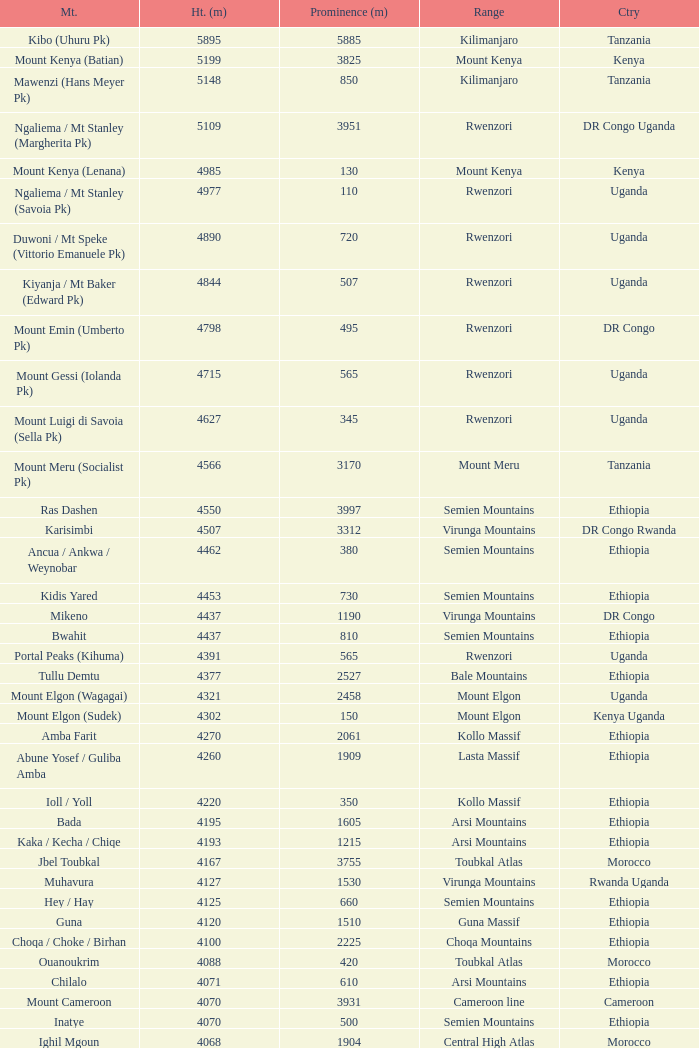Which Country has a Height (m) larger than 4100, and a Range of arsi mountains, and a Mountain of bada? Ethiopia. Can you give me this table as a dict? {'header': ['Mt.', 'Ht. (m)', 'Prominence (m)', 'Range', 'Ctry'], 'rows': [['Kibo (Uhuru Pk)', '5895', '5885', 'Kilimanjaro', 'Tanzania'], ['Mount Kenya (Batian)', '5199', '3825', 'Mount Kenya', 'Kenya'], ['Mawenzi (Hans Meyer Pk)', '5148', '850', 'Kilimanjaro', 'Tanzania'], ['Ngaliema / Mt Stanley (Margherita Pk)', '5109', '3951', 'Rwenzori', 'DR Congo Uganda'], ['Mount Kenya (Lenana)', '4985', '130', 'Mount Kenya', 'Kenya'], ['Ngaliema / Mt Stanley (Savoia Pk)', '4977', '110', 'Rwenzori', 'Uganda'], ['Duwoni / Mt Speke (Vittorio Emanuele Pk)', '4890', '720', 'Rwenzori', 'Uganda'], ['Kiyanja / Mt Baker (Edward Pk)', '4844', '507', 'Rwenzori', 'Uganda'], ['Mount Emin (Umberto Pk)', '4798', '495', 'Rwenzori', 'DR Congo'], ['Mount Gessi (Iolanda Pk)', '4715', '565', 'Rwenzori', 'Uganda'], ['Mount Luigi di Savoia (Sella Pk)', '4627', '345', 'Rwenzori', 'Uganda'], ['Mount Meru (Socialist Pk)', '4566', '3170', 'Mount Meru', 'Tanzania'], ['Ras Dashen', '4550', '3997', 'Semien Mountains', 'Ethiopia'], ['Karisimbi', '4507', '3312', 'Virunga Mountains', 'DR Congo Rwanda'], ['Ancua / Ankwa / Weynobar', '4462', '380', 'Semien Mountains', 'Ethiopia'], ['Kidis Yared', '4453', '730', 'Semien Mountains', 'Ethiopia'], ['Mikeno', '4437', '1190', 'Virunga Mountains', 'DR Congo'], ['Bwahit', '4437', '810', 'Semien Mountains', 'Ethiopia'], ['Portal Peaks (Kihuma)', '4391', '565', 'Rwenzori', 'Uganda'], ['Tullu Demtu', '4377', '2527', 'Bale Mountains', 'Ethiopia'], ['Mount Elgon (Wagagai)', '4321', '2458', 'Mount Elgon', 'Uganda'], ['Mount Elgon (Sudek)', '4302', '150', 'Mount Elgon', 'Kenya Uganda'], ['Amba Farit', '4270', '2061', 'Kollo Massif', 'Ethiopia'], ['Abune Yosef / Guliba Amba', '4260', '1909', 'Lasta Massif', 'Ethiopia'], ['Ioll / Yoll', '4220', '350', 'Kollo Massif', 'Ethiopia'], ['Bada', '4195', '1605', 'Arsi Mountains', 'Ethiopia'], ['Kaka / Kecha / Chiqe', '4193', '1215', 'Arsi Mountains', 'Ethiopia'], ['Jbel Toubkal', '4167', '3755', 'Toubkal Atlas', 'Morocco'], ['Muhavura', '4127', '1530', 'Virunga Mountains', 'Rwanda Uganda'], ['Hey / Hay', '4125', '660', 'Semien Mountains', 'Ethiopia'], ['Guna', '4120', '1510', 'Guna Massif', 'Ethiopia'], ['Choqa / Choke / Birhan', '4100', '2225', 'Choqa Mountains', 'Ethiopia'], ['Ouanoukrim', '4088', '420', 'Toubkal Atlas', 'Morocco'], ['Chilalo', '4071', '610', 'Arsi Mountains', 'Ethiopia'], ['Mount Cameroon', '4070', '3931', 'Cameroon line', 'Cameroon'], ['Inatye', '4070', '500', 'Semien Mountains', 'Ethiopia'], ['Ighil Mgoun', '4068', '1904', 'Central High Atlas', 'Morocco'], ['Weshema / Wasema?', '4030', '420', 'Bale Mountains', 'Ethiopia'], ['Oldoinyo Lesatima', '4001', '2081', 'Aberdare Range', 'Kenya'], ["Jebel n'Tarourt / Tifnout / Iferouane", '3996', '910', 'Toubkal Atlas', 'Morocco'], ['Muggia', '3950', '500', 'Lasta Massif', 'Ethiopia'], ['Dubbai', '3941', '1540', 'Tigray Mountains', 'Ethiopia'], ['Taska n’Zat', '3912', '460', 'Toubkal Atlas', 'Morocco'], ['Aksouâl', '3903', '450', 'Toubkal Atlas', 'Morocco'], ['Mount Kinangop', '3902', '530', 'Aberdare Range', 'Kenya'], ['Cimbia', '3900', '590', 'Kollo Massif', 'Ethiopia'], ['Anrhemer / Ingehmar', '3892', '380', 'Toubkal Atlas', 'Morocco'], ['Ieciuol ?', '3840', '560', 'Kollo Massif', 'Ethiopia'], ['Kawa / Caua / Lajo', '3830', '475', 'Bale Mountains', 'Ethiopia'], ['Pt 3820', '3820', '450', 'Kollo Massif', 'Ethiopia'], ['Jbel Tignousti', '3819', '930', 'Central High Atlas', 'Morocco'], ['Filfo / Encuolo', '3805', '770', 'Arsi Mountains', 'Ethiopia'], ['Kosso Amba', '3805', '530', 'Lasta Massif', 'Ethiopia'], ['Jbel Ghat', '3781', '470', 'Central High Atlas', 'Morocco'], ['Baylamtu / Gavsigivla', '3777', '1120', 'Lasta Massif', 'Ethiopia'], ['Ouaougoulzat', '3763', '860', 'Central High Atlas', 'Morocco'], ['Somkaru', '3760', '530', 'Bale Mountains', 'Ethiopia'], ['Abieri', '3750', '780', 'Semien Mountains', 'Ethiopia'], ['Arin Ayachi', '3747', '1400', 'East High Atlas', 'Morocco'], ['Teide', '3718', '3718', 'Tenerife', 'Canary Islands'], ['Visoke / Bisoke', '3711', '585', 'Virunga Mountains', 'DR Congo Rwanda'], ['Sarenga', '3700', '1160', 'Tigray Mountains', 'Ethiopia'], ['Woti / Uoti', '3700', '1050', 'Eastern Escarpment', 'Ethiopia'], ['Pt 3700 (Kulsa?)', '3700', '490', 'Arsi Mountains', 'Ethiopia'], ['Loolmalassin', '3682', '2040', 'Crater Highlands', 'Tanzania'], ['Biala ?', '3680', '870', 'Lasta Massif', 'Ethiopia'], ['Azurki / Azourki', '3677', '790', 'Central High Atlas', 'Morocco'], ['Pt 3645', '3645', '910', 'Lasta Massif', 'Ethiopia'], ['Sabyinyo', '3634', '1010', 'Virunga Mountains', 'Rwanda DR Congo Uganda'], ['Mount Gurage / Guraghe', '3620', '1400', 'Gurage Mountains', 'Ethiopia'], ['Angour', '3616', '444', 'Toubkal Atlas', 'Morocco'], ['Jbel Igdat', '3615', '1609', 'West High Atlas', 'Morocco'], ["Jbel n'Anghomar", '3609', '1420', 'Central High Atlas', 'Morocco'], ['Yegura / Amba Moka', '3605', '420', 'Lasta Massif', 'Ethiopia'], ['Pt 3600 (Kitir?)', '3600', '870', 'Eastern Escarpment', 'Ethiopia'], ['Pt 3600', '3600', '610', 'Lasta Massif', 'Ethiopia'], ['Bar Meda high point', '3580', '520', 'Eastern Escarpment', 'Ethiopia'], ['Jbel Erdouz', '3579', '690', 'West High Atlas', 'Morocco'], ['Mount Gugu', '3570', '940', 'Mount Gugu', 'Ethiopia'], ['Gesh Megal (?)', '3570', '520', 'Gurage Mountains', 'Ethiopia'], ['Gughe', '3568', '2013', 'Balta Mountains', 'Ethiopia'], ['Megezez', '3565', '690', 'Eastern Escarpment', 'Ethiopia'], ['Pt 3555', '3555', '475', 'Lasta Massif', 'Ethiopia'], ['Jbel Tinergwet', '3551', '880', 'West High Atlas', 'Morocco'], ['Amba Alagi', '3550', '820', 'Tigray Mountains', 'Ethiopia'], ['Nakugen', '3530', '1510', 'Cherangany Hills', 'Kenya'], ['Gara Guda /Kara Gada', '3530', '900', 'Salale Mountains', 'Ethiopia'], ['Amonewas', '3530', '870', 'Choqa Mountains', 'Ethiopia'], ['Amedamit', '3530', '760', 'Choqa Mountains', 'Ethiopia'], ['Igoudamene', '3519', '550', 'Central High Atlas', 'Morocco'], ['Abuye Meda', '3505', '230', 'Eastern Escarpment', 'Ethiopia'], ['Thabana Ntlenyana', '3482', '2390', 'Drakensberg', 'Lesotho'], ['Mont Mohi', '3480', '1592', 'Mitumba Mountains', 'DR Congo'], ['Gahinga', '3474', '425', 'Virunga Mountains', 'Uganda Rwanda'], ['Nyiragongo', '3470', '1440', 'Virunga Mountains', 'DR Congo']]} 